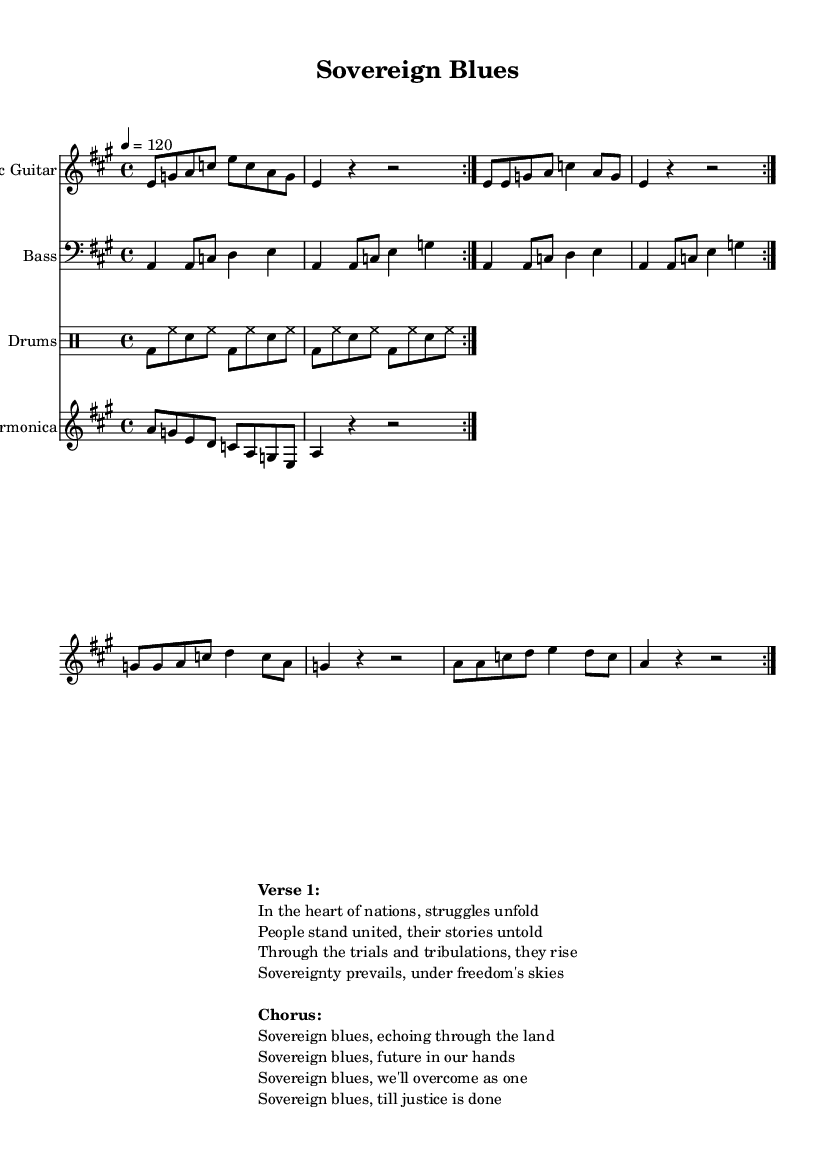What is the key signature of this music? The key signature is A major, which has three sharps (F#, C#, and G#). It indicates that most of the notes played in this piece will correspond with the notes from the A major scale.
Answer: A major What is the time signature of the music? The time signature is 4/4, which means there are four beats in each measure and a quarter note receives one beat.
Answer: 4/4 What is the tempo marking given in the music? The tempo marking is indicated as "4 = 120," which means the piece is played at a tempo of 120 beats per minute, with each beat represented by a quarter note.
Answer: 120 How many times is the electric guitar part repeated? The electric guitar part is marked with a repeat sign, indicating that it is to be played two times in succession before moving on to the next section.
Answer: 2 What is the instrumentation used in this composition? The instrumentation includes Electric Guitar, Bass, Drums, and Harmonica. These instruments are characteristic of the Electric Blues genre, providing the typical sound and texture for the style.
Answer: Electric Guitar, Bass, Drums, and Harmonica What lyrical theme is explored in the song? The song explores themes of sovereignty and resilience, emphasizing people's struggles and unity in the face of political challenges, as reflected in the verses and chorus.
Answer: Sovereignty and resilience 